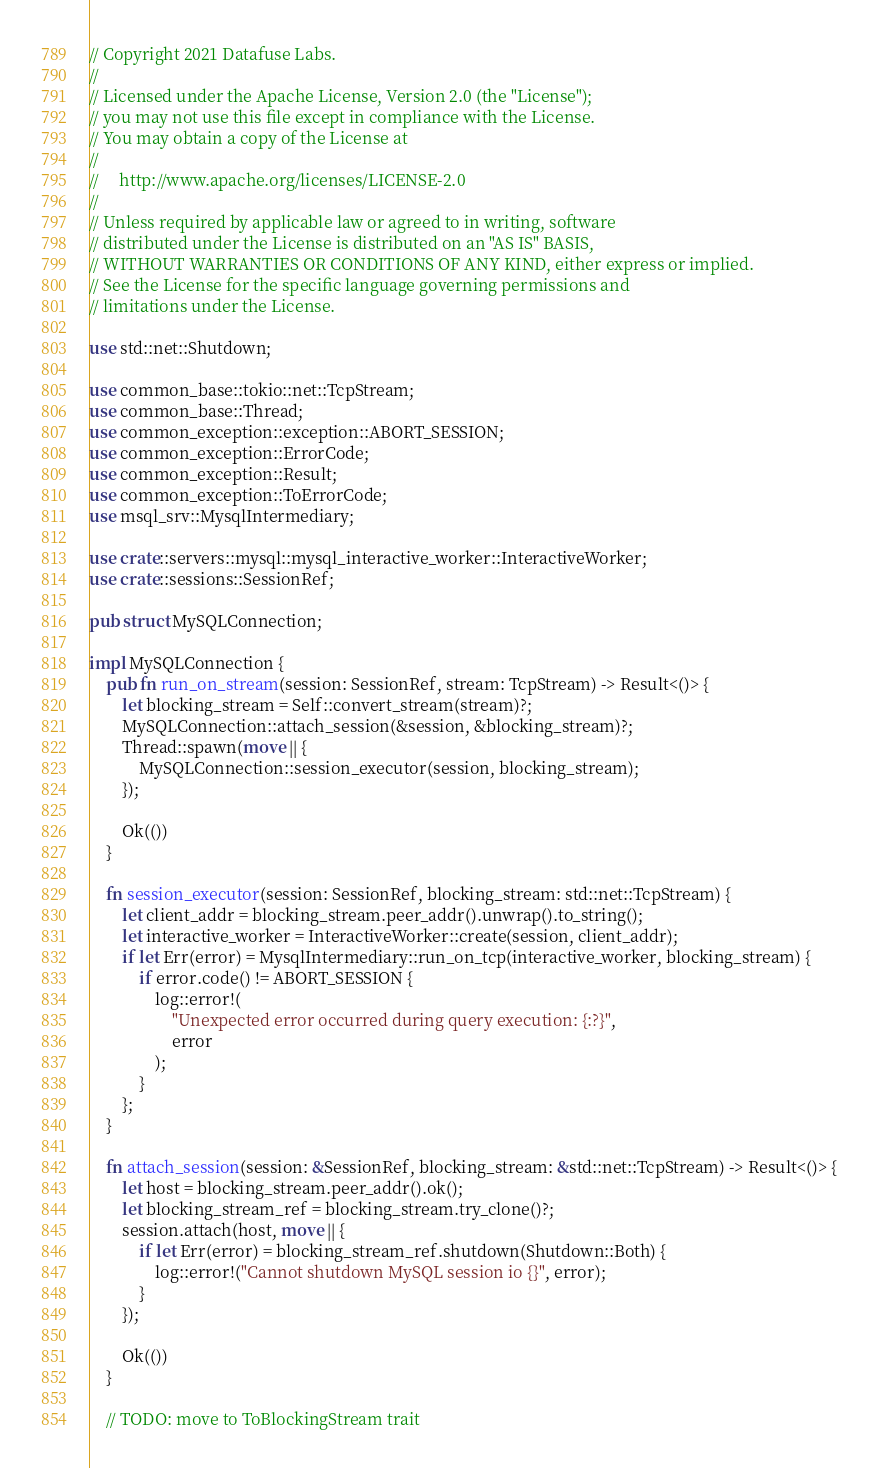<code> <loc_0><loc_0><loc_500><loc_500><_Rust_>// Copyright 2021 Datafuse Labs.
//
// Licensed under the Apache License, Version 2.0 (the "License");
// you may not use this file except in compliance with the License.
// You may obtain a copy of the License at
//
//     http://www.apache.org/licenses/LICENSE-2.0
//
// Unless required by applicable law or agreed to in writing, software
// distributed under the License is distributed on an "AS IS" BASIS,
// WITHOUT WARRANTIES OR CONDITIONS OF ANY KIND, either express or implied.
// See the License for the specific language governing permissions and
// limitations under the License.

use std::net::Shutdown;

use common_base::tokio::net::TcpStream;
use common_base::Thread;
use common_exception::exception::ABORT_SESSION;
use common_exception::ErrorCode;
use common_exception::Result;
use common_exception::ToErrorCode;
use msql_srv::MysqlIntermediary;

use crate::servers::mysql::mysql_interactive_worker::InteractiveWorker;
use crate::sessions::SessionRef;

pub struct MySQLConnection;

impl MySQLConnection {
    pub fn run_on_stream(session: SessionRef, stream: TcpStream) -> Result<()> {
        let blocking_stream = Self::convert_stream(stream)?;
        MySQLConnection::attach_session(&session, &blocking_stream)?;
        Thread::spawn(move || {
            MySQLConnection::session_executor(session, blocking_stream);
        });

        Ok(())
    }

    fn session_executor(session: SessionRef, blocking_stream: std::net::TcpStream) {
        let client_addr = blocking_stream.peer_addr().unwrap().to_string();
        let interactive_worker = InteractiveWorker::create(session, client_addr);
        if let Err(error) = MysqlIntermediary::run_on_tcp(interactive_worker, blocking_stream) {
            if error.code() != ABORT_SESSION {
                log::error!(
                    "Unexpected error occurred during query execution: {:?}",
                    error
                );
            }
        };
    }

    fn attach_session(session: &SessionRef, blocking_stream: &std::net::TcpStream) -> Result<()> {
        let host = blocking_stream.peer_addr().ok();
        let blocking_stream_ref = blocking_stream.try_clone()?;
        session.attach(host, move || {
            if let Err(error) = blocking_stream_ref.shutdown(Shutdown::Both) {
                log::error!("Cannot shutdown MySQL session io {}", error);
            }
        });

        Ok(())
    }

    // TODO: move to ToBlockingStream trait</code> 